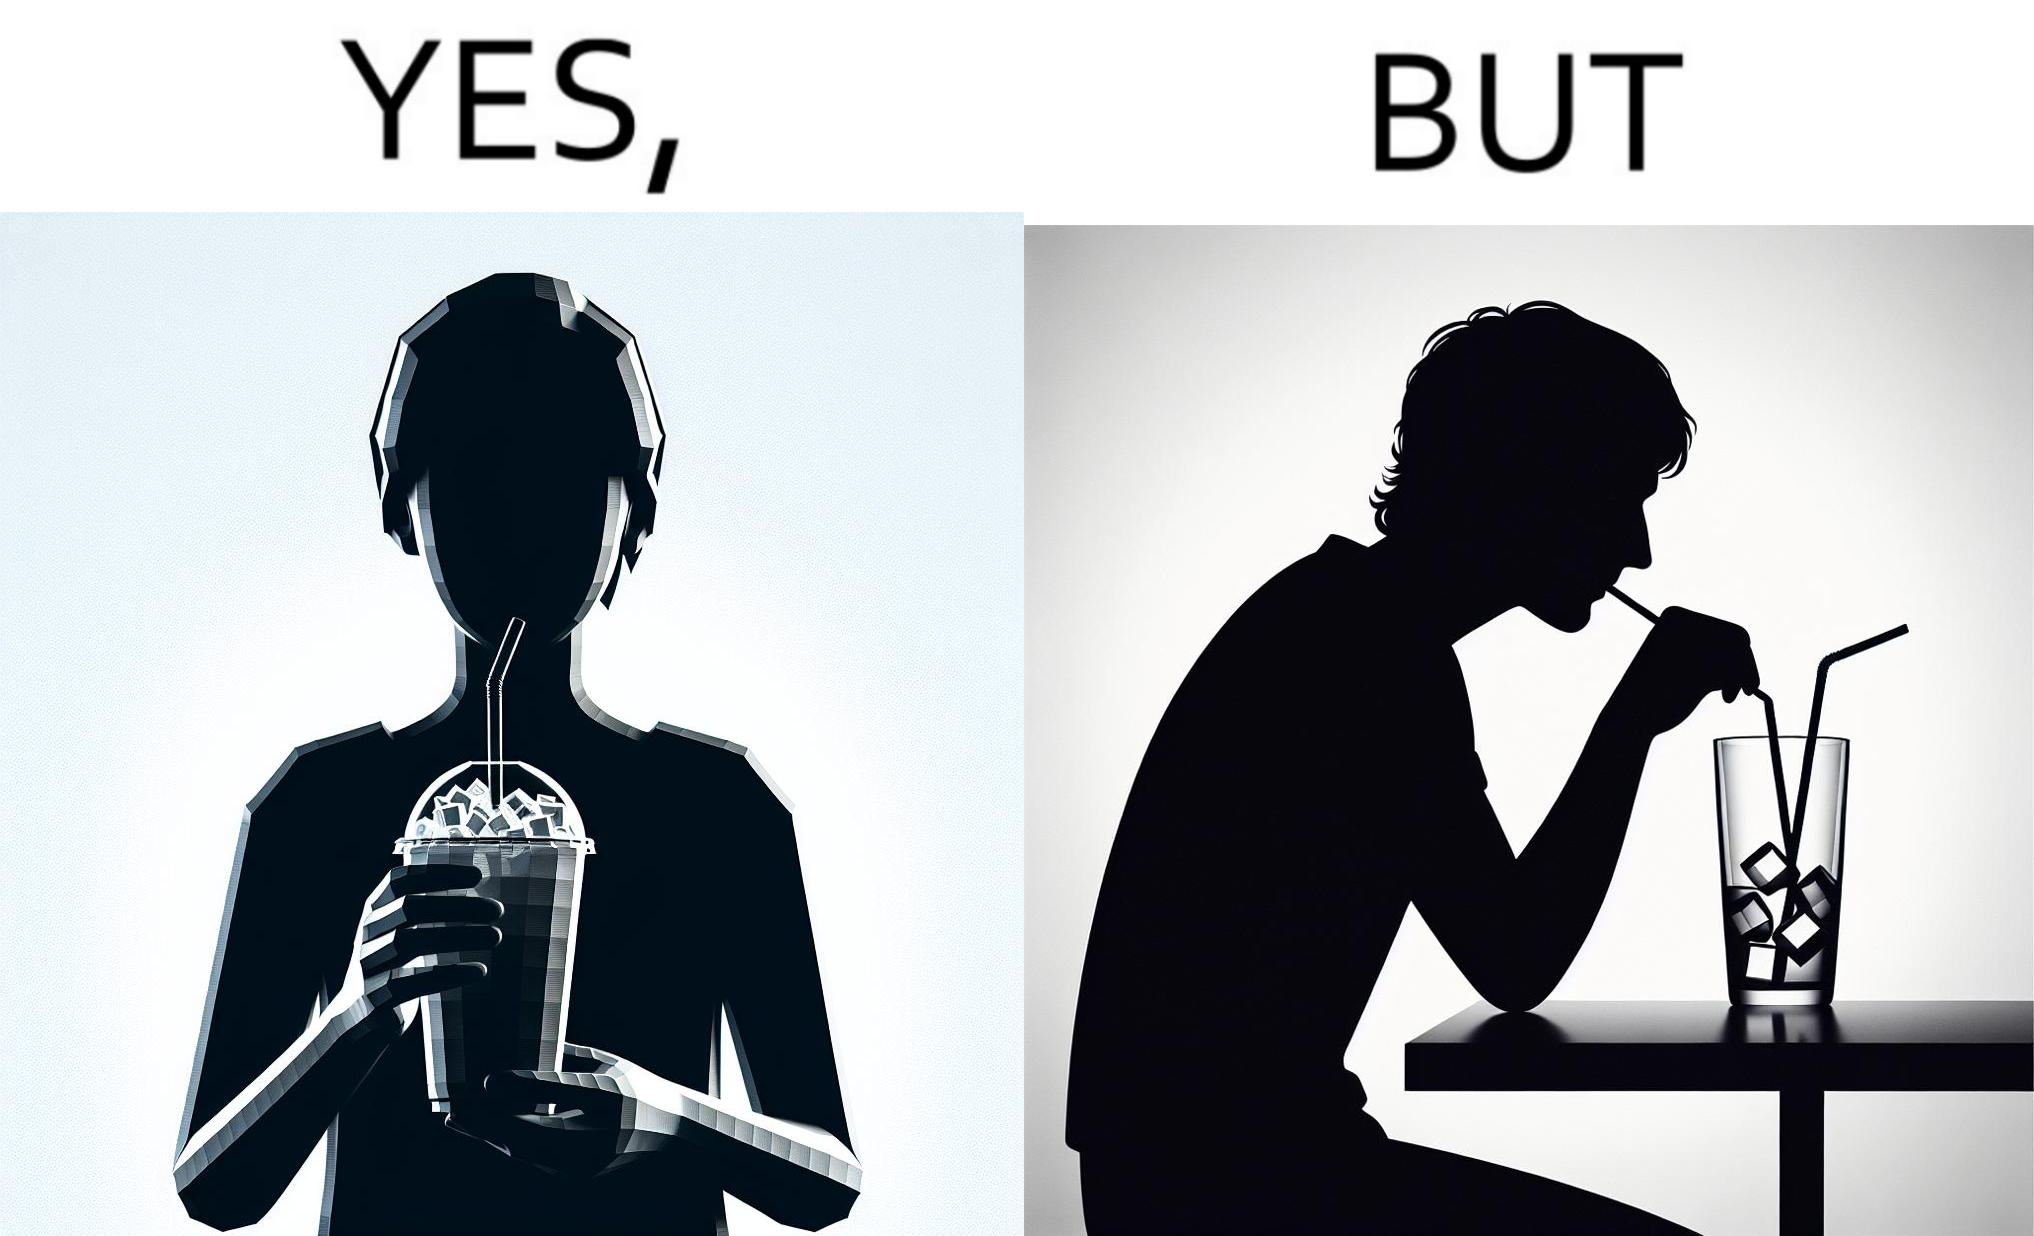What do you see in each half of this image? In the left part of the image: A person holding a drink with ice cubes, with a straw in the drink. In the right part of the image: A person drinking out of a straw from a drink. The drink is almost finished, and only I've cubes are left. 